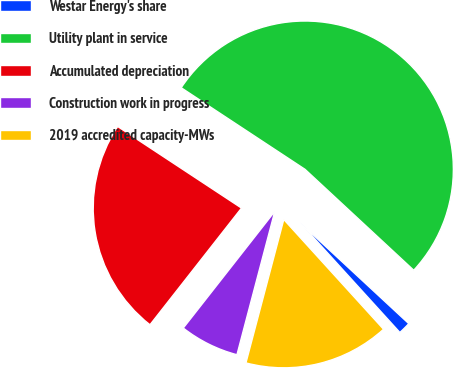<chart> <loc_0><loc_0><loc_500><loc_500><pie_chart><fcel>Westar Energy's share<fcel>Utility plant in service<fcel>Accumulated depreciation<fcel>Construction work in progress<fcel>2019 accredited capacity-MWs<nl><fcel>1.35%<fcel>52.64%<fcel>23.69%<fcel>6.48%<fcel>15.85%<nl></chart> 